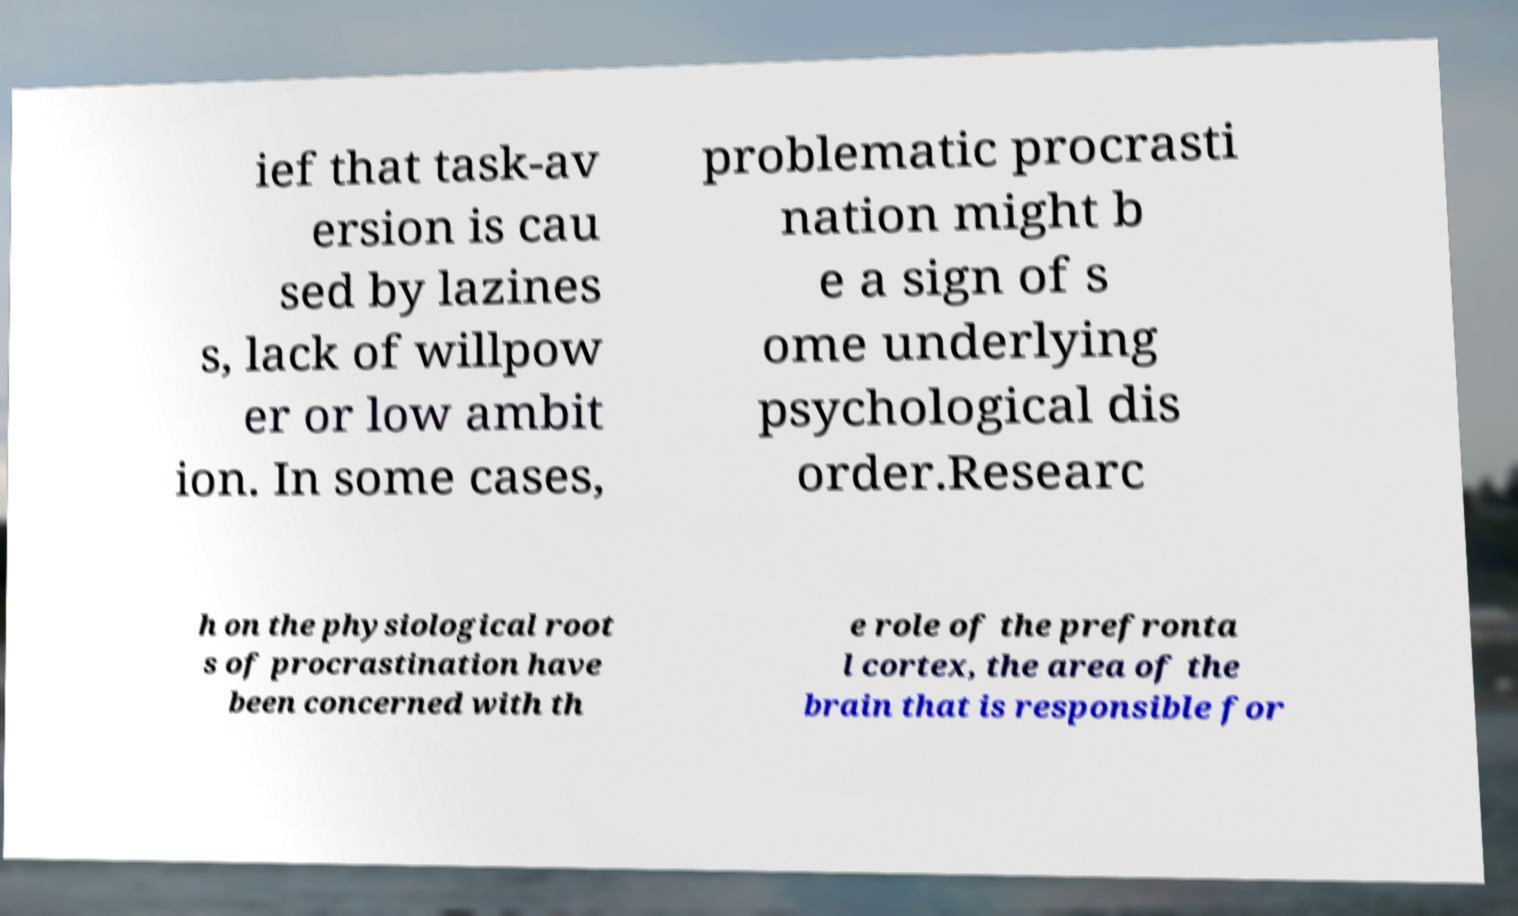Could you assist in decoding the text presented in this image and type it out clearly? ief that task-av ersion is cau sed by lazines s, lack of willpow er or low ambit ion. In some cases, problematic procrasti nation might b e a sign of s ome underlying psychological dis order.Researc h on the physiological root s of procrastination have been concerned with th e role of the prefronta l cortex, the area of the brain that is responsible for 